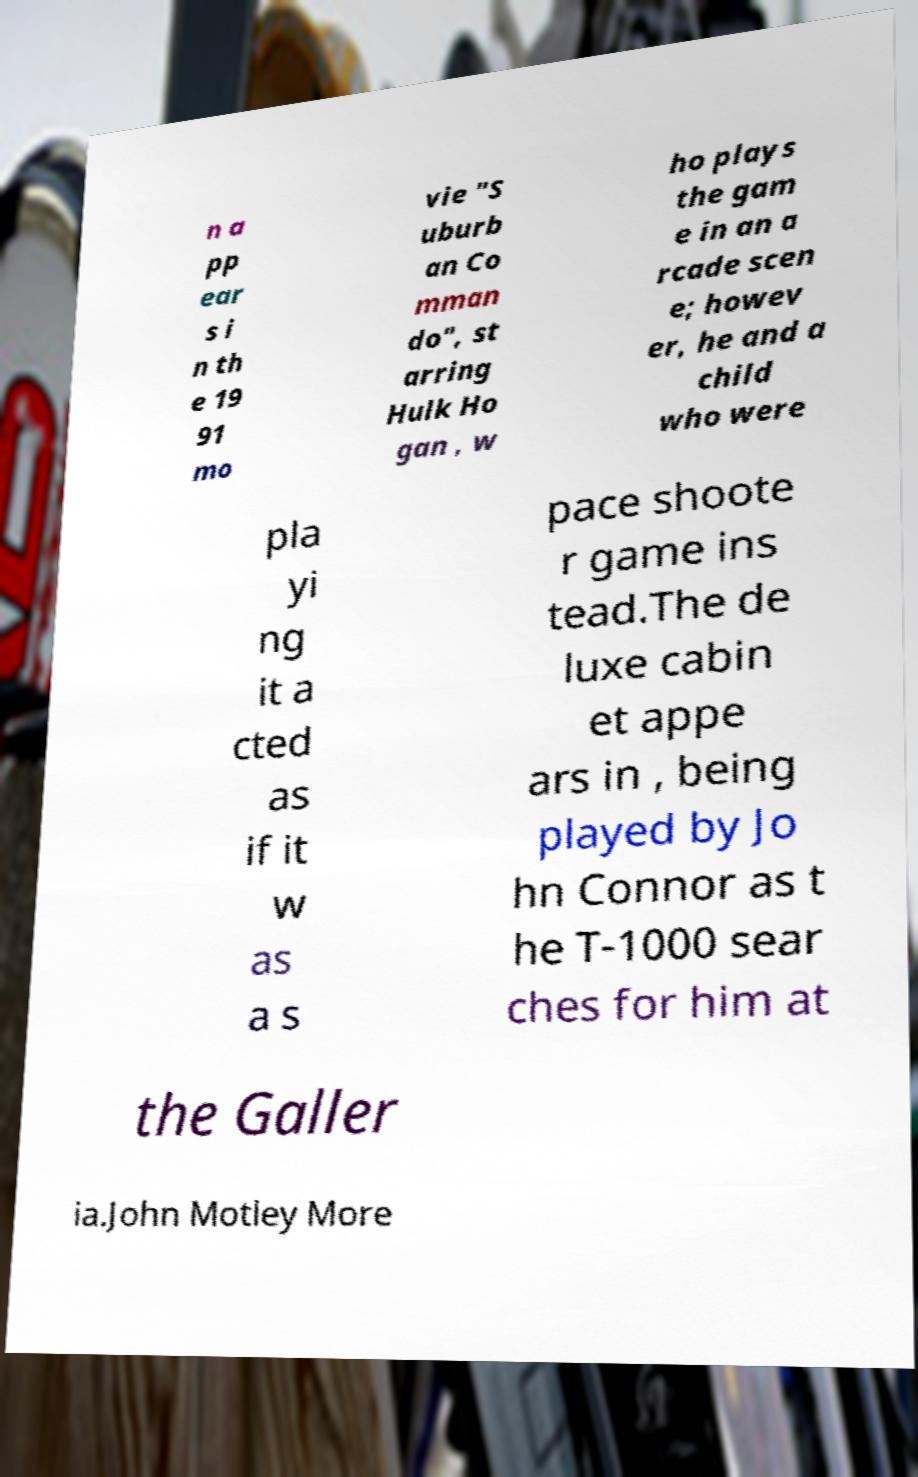Can you read and provide the text displayed in the image?This photo seems to have some interesting text. Can you extract and type it out for me? n a pp ear s i n th e 19 91 mo vie "S uburb an Co mman do", st arring Hulk Ho gan , w ho plays the gam e in an a rcade scen e; howev er, he and a child who were pla yi ng it a cted as if it w as a s pace shoote r game ins tead.The de luxe cabin et appe ars in , being played by Jo hn Connor as t he T-1000 sear ches for him at the Galler ia.John Motley More 